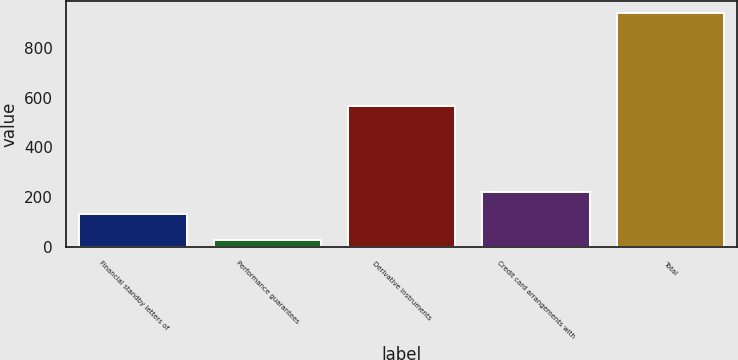Convert chart. <chart><loc_0><loc_0><loc_500><loc_500><bar_chart><fcel>Financial standby letters of<fcel>Performance guarantees<fcel>Derivative instruments<fcel>Credit card arrangements with<fcel>Total<nl><fcel>131<fcel>29<fcel>567<fcel>222<fcel>939<nl></chart> 